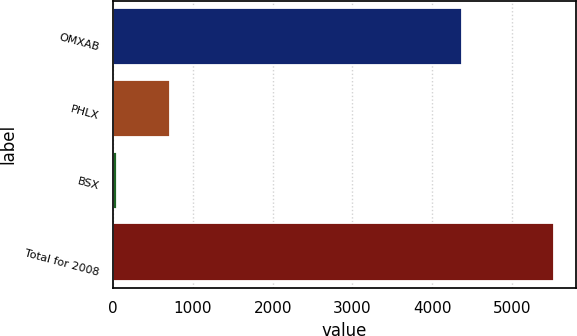Convert chart to OTSL. <chart><loc_0><loc_0><loc_500><loc_500><bar_chart><fcel>OMXAB<fcel>PHLX<fcel>BSX<fcel>Total for 2008<nl><fcel>4371<fcel>708<fcel>43<fcel>5524<nl></chart> 